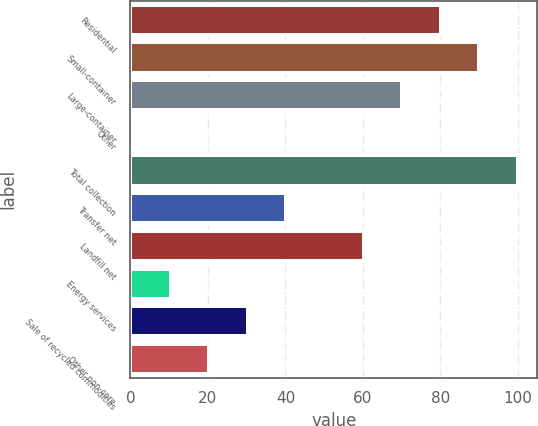Convert chart. <chart><loc_0><loc_0><loc_500><loc_500><bar_chart><fcel>Residential<fcel>Small-container<fcel>Large-container<fcel>Other<fcel>Total collection<fcel>Transfer net<fcel>Landfill net<fcel>Energy services<fcel>Sale of recycled commodities<fcel>Other non-core<nl><fcel>80.08<fcel>90.04<fcel>70.12<fcel>0.4<fcel>100<fcel>40.24<fcel>60.16<fcel>10.36<fcel>30.28<fcel>20.32<nl></chart> 